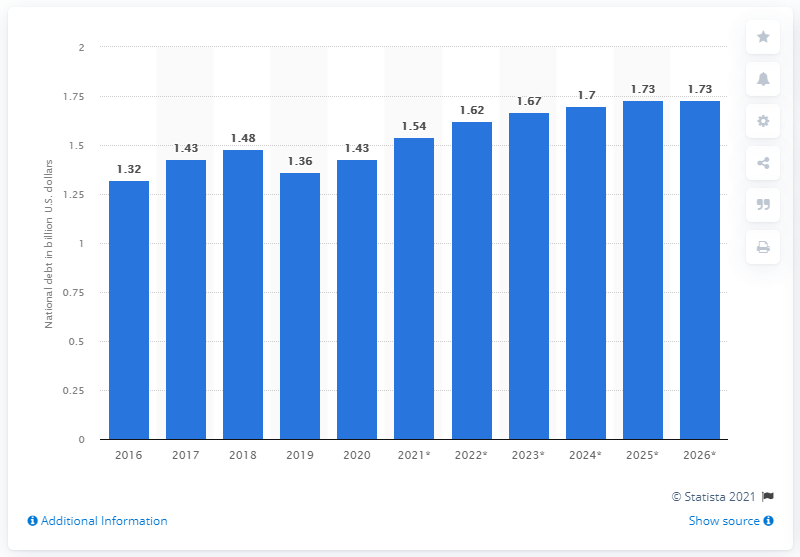List a handful of essential elements in this visual. The national debt of Antigua and Barbuda was in 2016. As of 2019, the national debt of Antigua and Barbuda was 1.36 trillion dollars. 